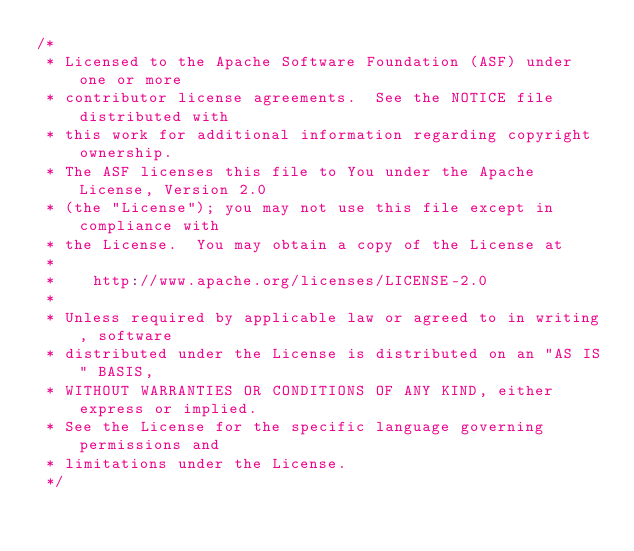Convert code to text. <code><loc_0><loc_0><loc_500><loc_500><_Scala_>/*
 * Licensed to the Apache Software Foundation (ASF) under one or more
 * contributor license agreements.  See the NOTICE file distributed with
 * this work for additional information regarding copyright ownership.
 * The ASF licenses this file to You under the Apache License, Version 2.0
 * (the "License"); you may not use this file except in compliance with
 * the License.  You may obtain a copy of the License at
 *
 *    http://www.apache.org/licenses/LICENSE-2.0
 *
 * Unless required by applicable law or agreed to in writing, software
 * distributed under the License is distributed on an "AS IS" BASIS,
 * WITHOUT WARRANTIES OR CONDITIONS OF ANY KIND, either express or implied.
 * See the License for the specific language governing permissions and
 * limitations under the License.
 */
</code> 